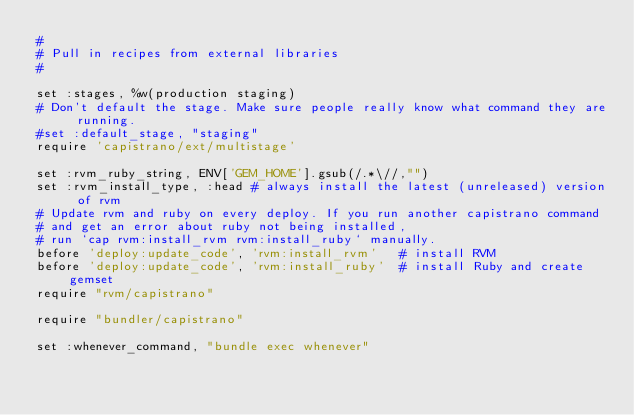<code> <loc_0><loc_0><loc_500><loc_500><_Ruby_>#
# Pull in recipes from external libraries
#

set :stages, %w(production staging)
# Don't default the stage. Make sure people really know what command they are running.
#set :default_stage, "staging"
require 'capistrano/ext/multistage'

set :rvm_ruby_string, ENV['GEM_HOME'].gsub(/.*\//,"")
set :rvm_install_type, :head # always install the latest (unreleased) version of rvm
# Update rvm and ruby on every deploy. If you run another capistrano command
# and get an error about ruby not being installed, 
# run `cap rvm:install_rvm rvm:install_ruby` manually.
before 'deploy:update_code', 'rvm:install_rvm'   # install RVM
before 'deploy:update_code', 'rvm:install_ruby'  # install Ruby and create gemset
require "rvm/capistrano"

require "bundler/capistrano"

set :whenever_command, "bundle exec whenever"</code> 